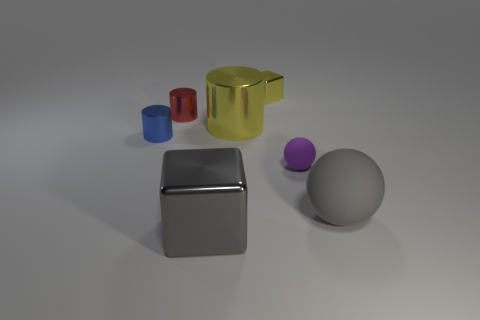Add 1 small purple spheres. How many objects exist? 8 Subtract all cubes. How many objects are left? 5 Add 4 large balls. How many large balls exist? 5 Subtract 1 purple balls. How many objects are left? 6 Subtract all big matte spheres. Subtract all metal objects. How many objects are left? 1 Add 5 yellow objects. How many yellow objects are left? 7 